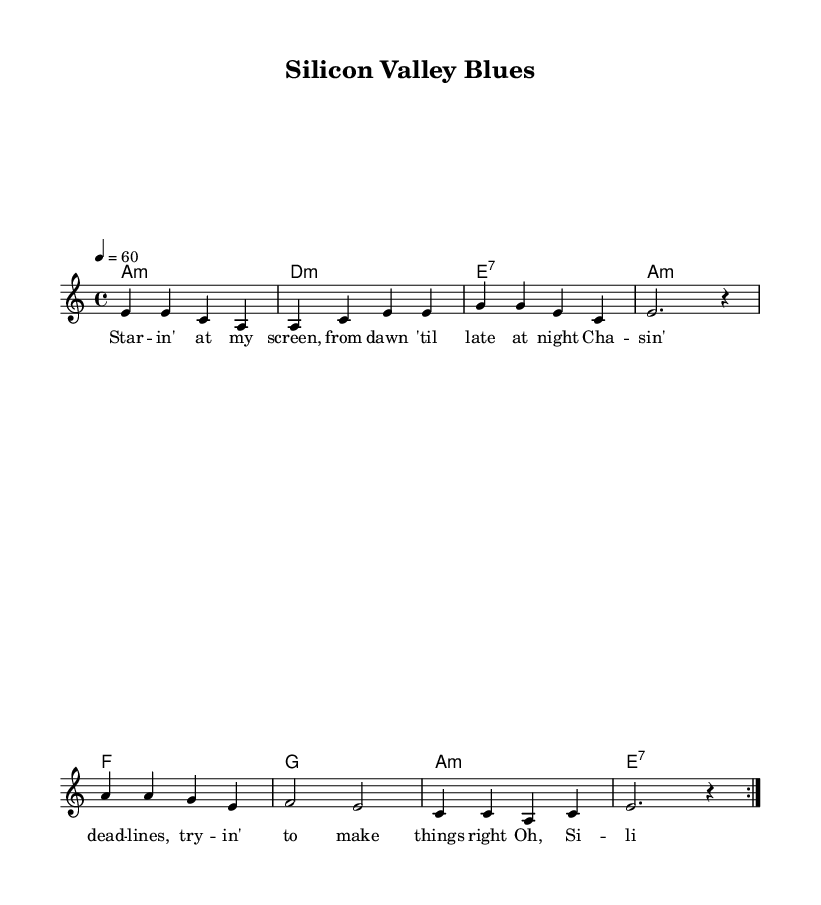What is the key signature of this music? The key signature indicated is A minor, which contains no sharps or flats. This can be confirmed by looking at the beginning of the staff where the key signature is shown.
Answer: A minor What is the time signature of the sheet music? The time signature displayed at the beginning is 4/4, meaning there are four beats in each measure and the quarter note gets one beat. This can be identified at the start of the score.
Answer: 4/4 What is the tempo marking in this piece? The tempo marking is given as 4 = 60, indicating that there are 60 beats per minute. This is typically seen below the header or at the beginning of the score.
Answer: 60 How many measures are in the main melody? The main melody contains a total of eight measures, which can be counted by looking at the grouping of notes and bar lines in the melody section.
Answer: Eight measures What is the structure of the verses in this blues song? The structure consists of two repeated verses, as indicated by the repeat sign (volta) near the melody, which shows that the first part is revisited. This is typical in blues music, where repetition is key.
Answer: Two repeated verses What kind of chord progression is used in this blues piece? The chord progression follows a common blues pattern, specifically a minor and dominant seventh structure, which can be observed in the chord symbols above the melody staff.
Answer: Minor and dominant seventh chords What lyrical theme is reflected in this blues ballad? The lyrical theme centers around work-life balance and the struggles of working long hours in the tech industry, as evidenced by the lyrics that speak to longing and search for balance.
Answer: Work-life balance in the tech industry 